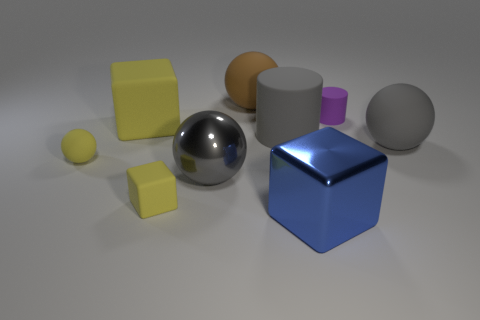What are the different materials depicted in the image? The image depicts various objects with materials that include polished metal for the reflective sphere and cube, matte rubber for the yellow and orange objects, and a rougher, possibly plastic material for the gray cylinder and purple cone. 